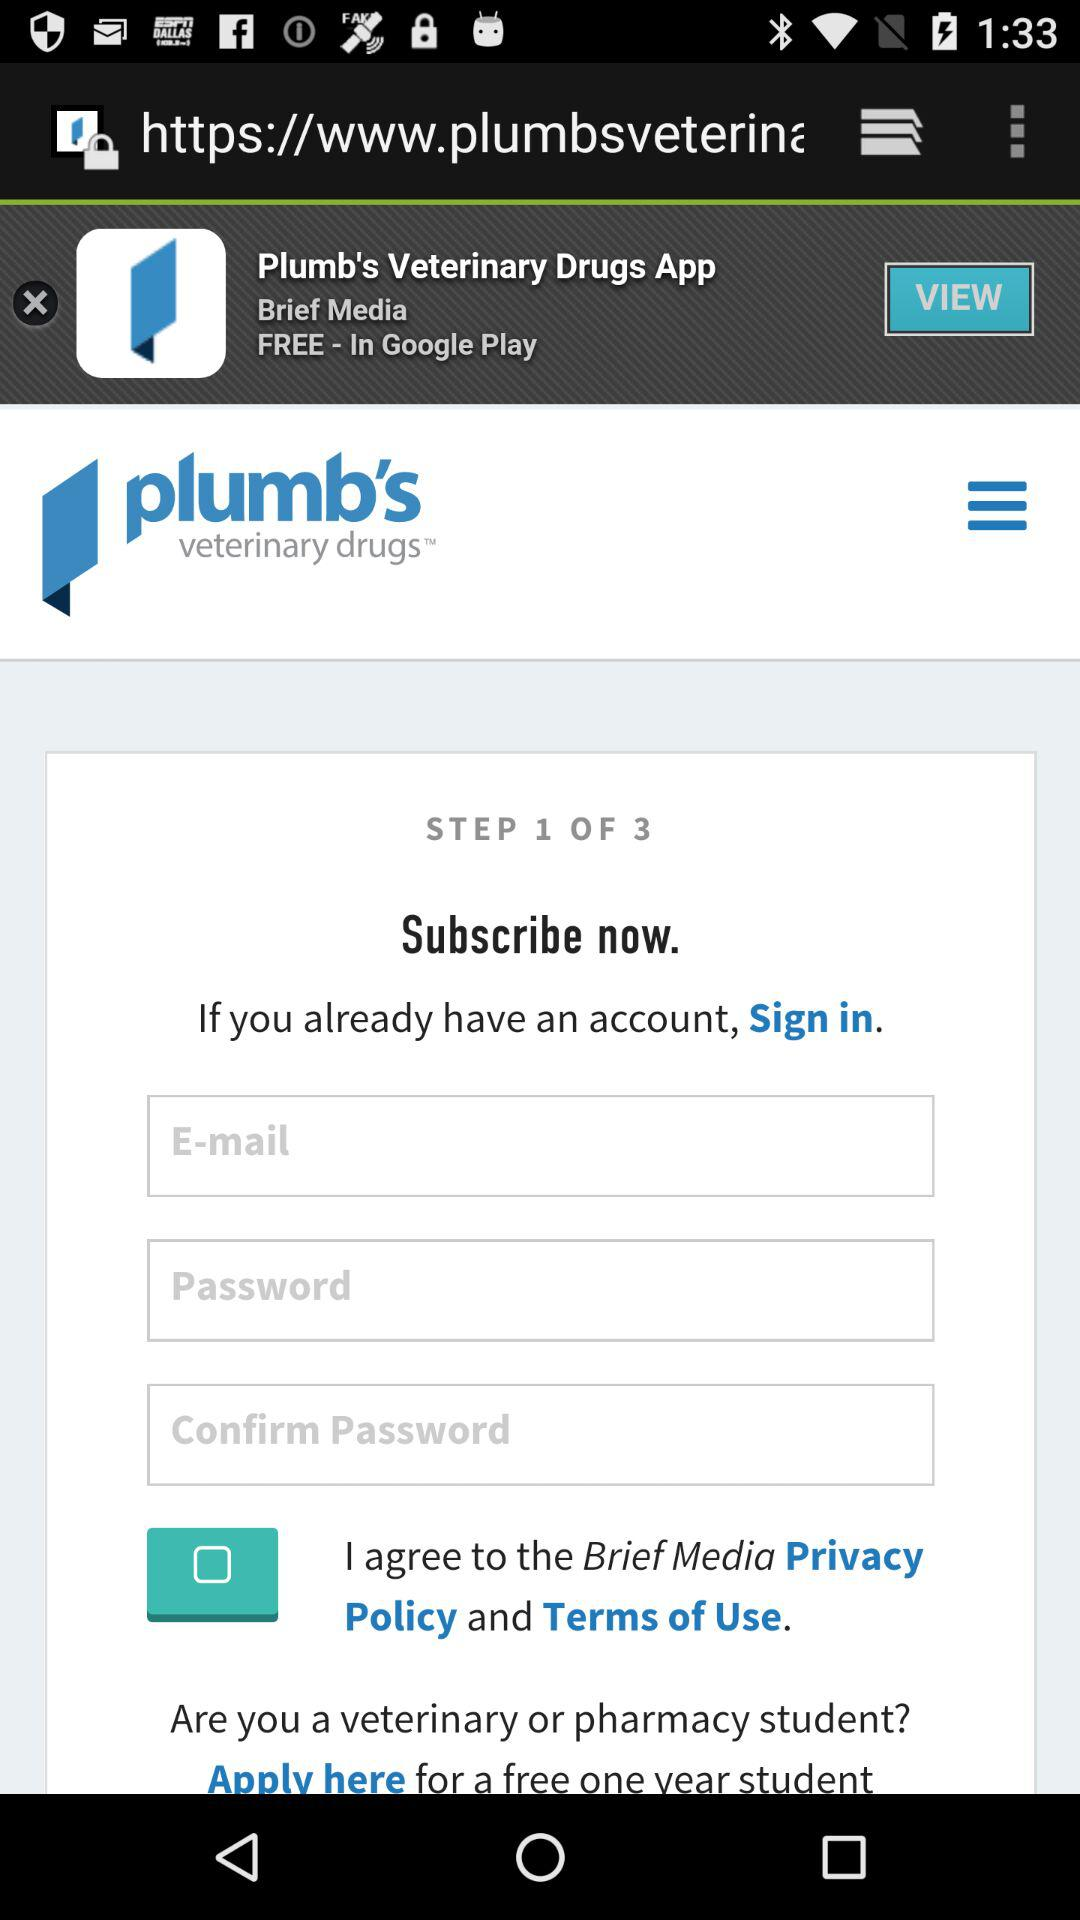What is the total number of steps? The total number of steps is 3. 